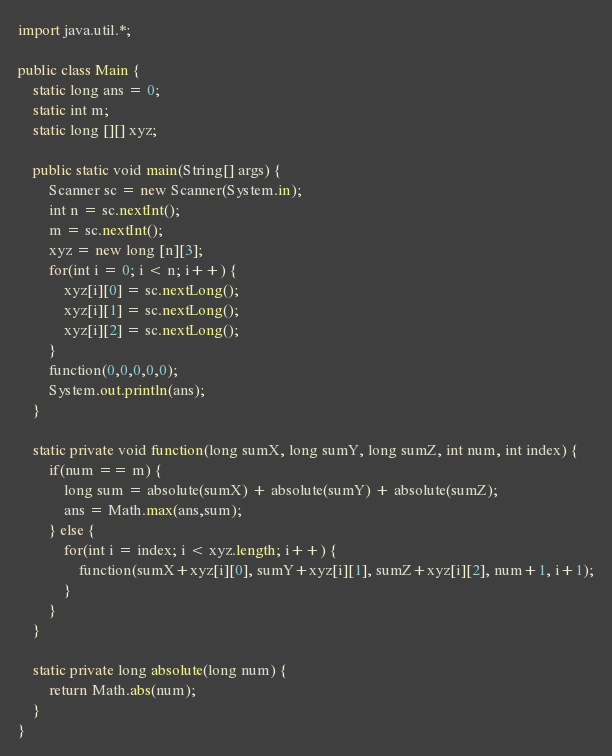<code> <loc_0><loc_0><loc_500><loc_500><_Java_>import java.util.*;
 
public class Main {
    static long ans = 0;
    static int m;
    static long [][] xyz;
    
    public static void main(String[] args) {
        Scanner sc = new Scanner(System.in);
        int n = sc.nextInt();
        m = sc.nextInt();
        xyz = new long [n][3];
        for(int i = 0; i < n; i++) {
            xyz[i][0] = sc.nextLong();
            xyz[i][1] = sc.nextLong();
            xyz[i][2] = sc.nextLong();
        }
        function(0,0,0,0,0);
        System.out.println(ans);
    }
    
    static private void function(long sumX, long sumY, long sumZ, int num, int index) {
        if(num == m) {
            long sum = absolute(sumX) + absolute(sumY) + absolute(sumZ);
            ans = Math.max(ans,sum);
        } else {
            for(int i = index; i < xyz.length; i++) {
                function(sumX+xyz[i][0], sumY+xyz[i][1], sumZ+xyz[i][2], num+1, i+1);
            }
        }
    }
    
    static private long absolute(long num) {
        return Math.abs(num);
    }
}</code> 